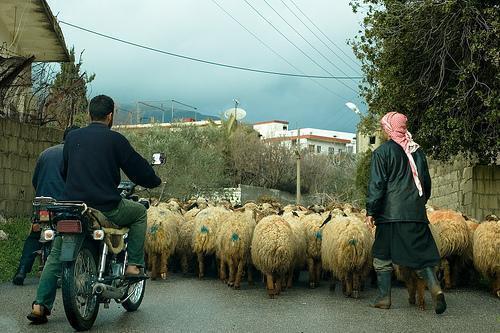How many motorcycles are there?
Give a very brief answer. 2. How many people are there?
Give a very brief answer. 3. How many sheep are visible?
Give a very brief answer. 2. How many horses are there?
Give a very brief answer. 0. 